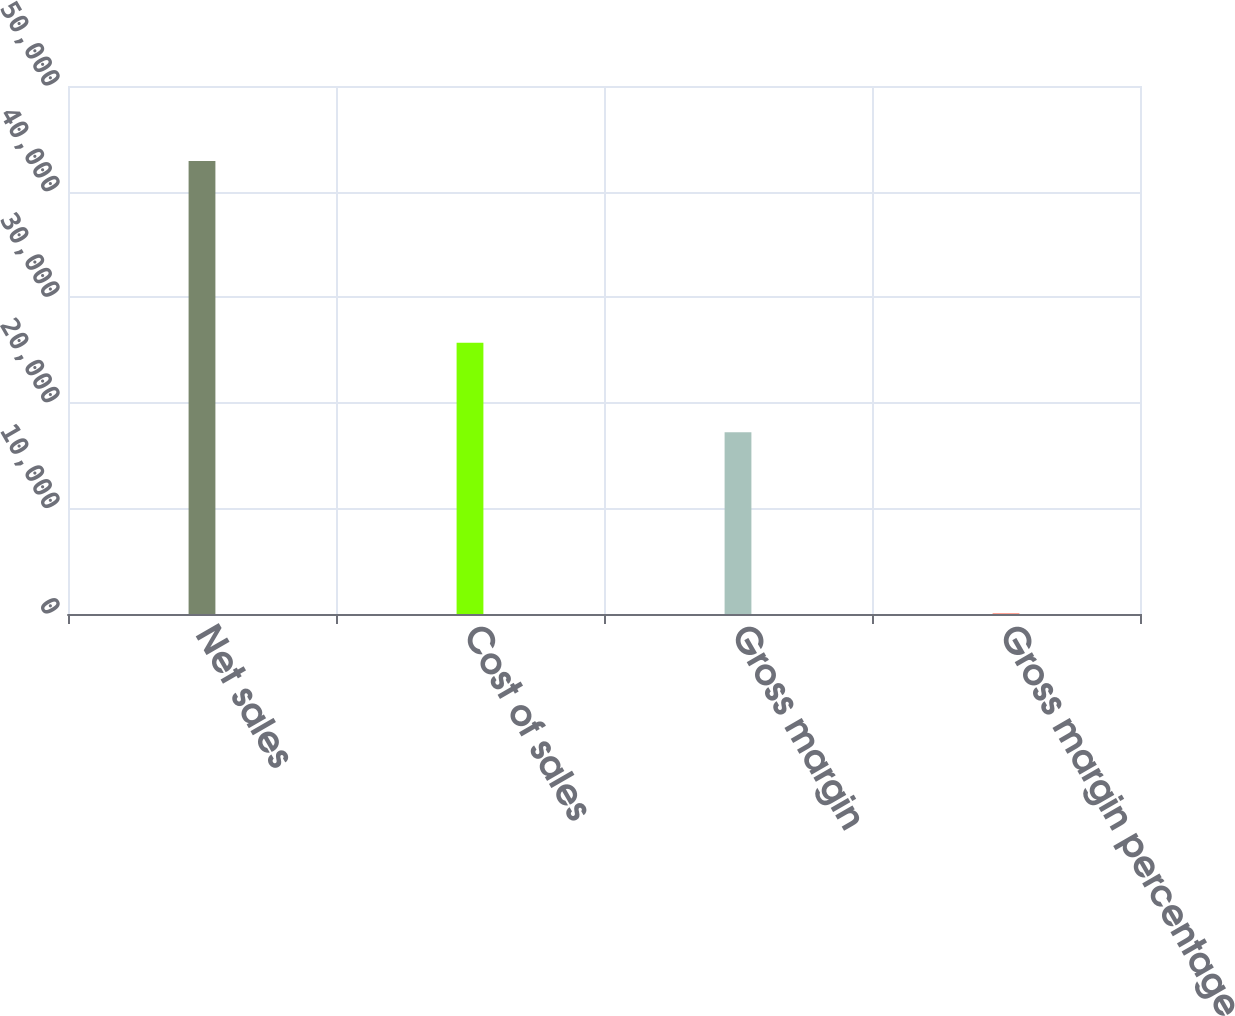<chart> <loc_0><loc_0><loc_500><loc_500><bar_chart><fcel>Net sales<fcel>Cost of sales<fcel>Gross margin<fcel>Gross margin percentage<nl><fcel>42905<fcel>25683<fcel>17222<fcel>40.1<nl></chart> 